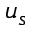<formula> <loc_0><loc_0><loc_500><loc_500>u _ { s }</formula> 